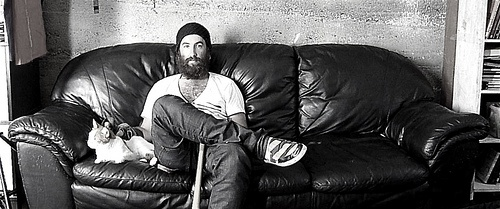Describe the objects in this image and their specific colors. I can see couch in whitesmoke, black, gray, darkgray, and lightgray tones, people in white, black, gray, and darkgray tones, cat in white, darkgray, gray, and black tones, and baseball bat in whitesmoke, white, black, darkgray, and gray tones in this image. 